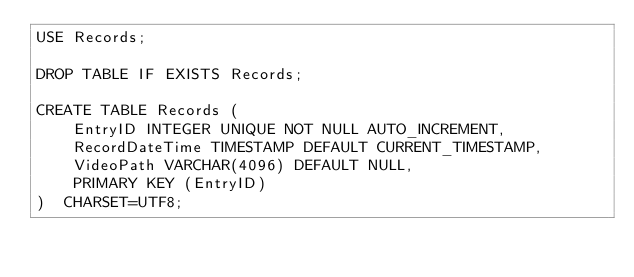<code> <loc_0><loc_0><loc_500><loc_500><_SQL_>USE Records;

DROP TABLE IF EXISTS Records;

CREATE TABLE Records (
    EntryID INTEGER UNIQUE NOT NULL AUTO_INCREMENT,
    RecordDateTime TIMESTAMP DEFAULT CURRENT_TIMESTAMP,
    VideoPath VARCHAR(4096) DEFAULT NULL,
    PRIMARY KEY (EntryID)
)  CHARSET=UTF8;

</code> 